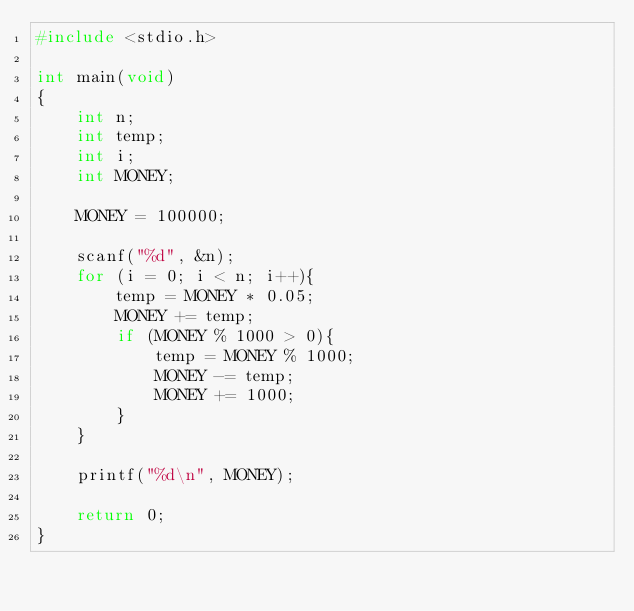Convert code to text. <code><loc_0><loc_0><loc_500><loc_500><_C_>#include <stdio.h>

int main(void)
{
	int n;
	int temp;
	int i;
	int MONEY;
	
	MONEY = 100000;
	
	scanf("%d", &n);
	for (i = 0; i < n; i++){
		temp = MONEY * 0.05;
		MONEY += temp;
		if (MONEY % 1000 > 0){
			temp = MONEY % 1000;
			MONEY -= temp;
			MONEY += 1000;
		}
	}
	
	printf("%d\n", MONEY);
	
	return 0;
}</code> 